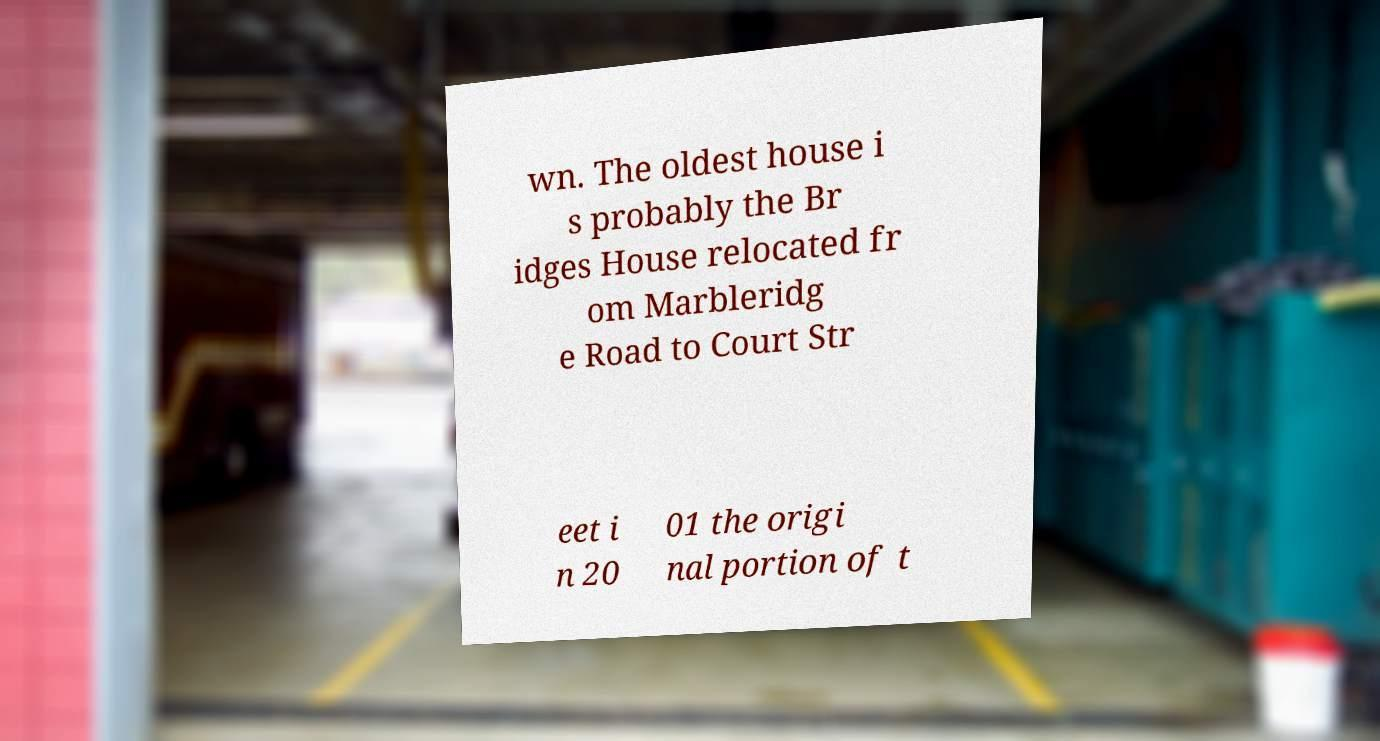For documentation purposes, I need the text within this image transcribed. Could you provide that? wn. The oldest house i s probably the Br idges House relocated fr om Marbleridg e Road to Court Str eet i n 20 01 the origi nal portion of t 